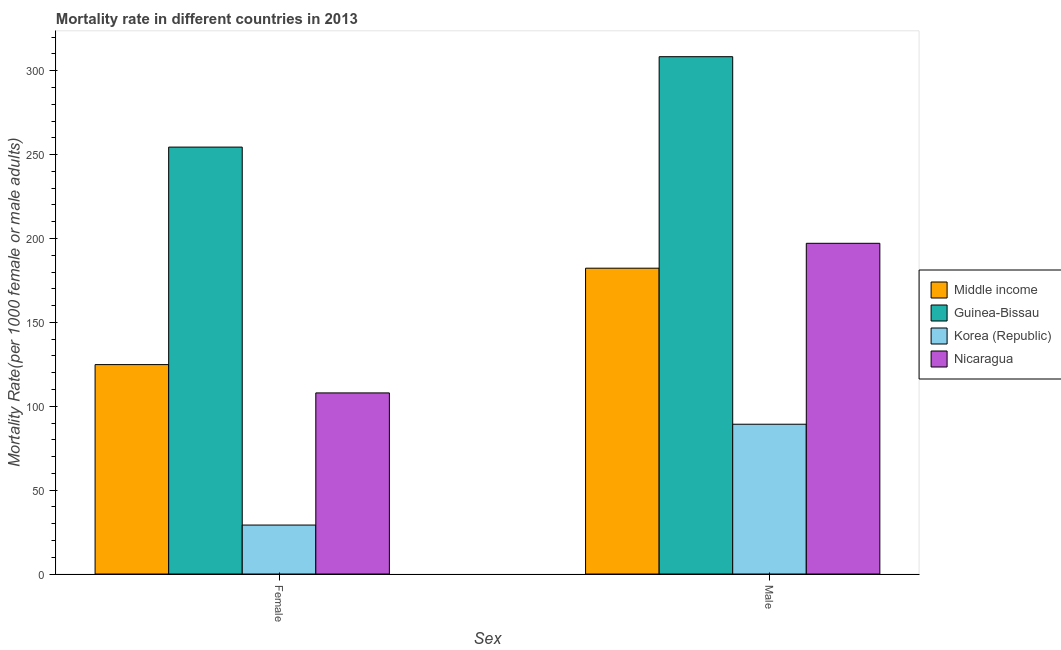How many different coloured bars are there?
Keep it short and to the point. 4. How many groups of bars are there?
Your response must be concise. 2. Are the number of bars per tick equal to the number of legend labels?
Keep it short and to the point. Yes. How many bars are there on the 1st tick from the right?
Offer a terse response. 4. What is the label of the 2nd group of bars from the left?
Provide a succinct answer. Male. What is the female mortality rate in Nicaragua?
Give a very brief answer. 107.94. Across all countries, what is the maximum female mortality rate?
Provide a short and direct response. 254.45. Across all countries, what is the minimum male mortality rate?
Your answer should be very brief. 89.27. In which country was the male mortality rate maximum?
Keep it short and to the point. Guinea-Bissau. In which country was the female mortality rate minimum?
Give a very brief answer. Korea (Republic). What is the total female mortality rate in the graph?
Keep it short and to the point. 516.38. What is the difference between the male mortality rate in Guinea-Bissau and that in Korea (Republic)?
Make the answer very short. 219.07. What is the difference between the female mortality rate in Korea (Republic) and the male mortality rate in Middle income?
Offer a very short reply. -153.11. What is the average female mortality rate per country?
Offer a terse response. 129.09. What is the difference between the female mortality rate and male mortality rate in Korea (Republic)?
Your answer should be compact. -60.1. In how many countries, is the female mortality rate greater than 120 ?
Your response must be concise. 2. What is the ratio of the male mortality rate in Korea (Republic) to that in Nicaragua?
Provide a short and direct response. 0.45. Is the male mortality rate in Middle income less than that in Guinea-Bissau?
Make the answer very short. Yes. In how many countries, is the male mortality rate greater than the average male mortality rate taken over all countries?
Offer a very short reply. 2. What does the 4th bar from the left in Male represents?
Make the answer very short. Nicaragua. How many bars are there?
Offer a terse response. 8. Are all the bars in the graph horizontal?
Provide a succinct answer. No. What is the difference between two consecutive major ticks on the Y-axis?
Provide a short and direct response. 50. Does the graph contain grids?
Your answer should be very brief. No. How many legend labels are there?
Offer a very short reply. 4. How are the legend labels stacked?
Make the answer very short. Vertical. What is the title of the graph?
Your answer should be very brief. Mortality rate in different countries in 2013. Does "Switzerland" appear as one of the legend labels in the graph?
Keep it short and to the point. No. What is the label or title of the X-axis?
Provide a succinct answer. Sex. What is the label or title of the Y-axis?
Provide a succinct answer. Mortality Rate(per 1000 female or male adults). What is the Mortality Rate(per 1000 female or male adults) in Middle income in Female?
Make the answer very short. 124.82. What is the Mortality Rate(per 1000 female or male adults) of Guinea-Bissau in Female?
Your answer should be very brief. 254.45. What is the Mortality Rate(per 1000 female or male adults) in Korea (Republic) in Female?
Give a very brief answer. 29.17. What is the Mortality Rate(per 1000 female or male adults) in Nicaragua in Female?
Ensure brevity in your answer.  107.94. What is the Mortality Rate(per 1000 female or male adults) in Middle income in Male?
Keep it short and to the point. 182.28. What is the Mortality Rate(per 1000 female or male adults) of Guinea-Bissau in Male?
Your answer should be very brief. 308.34. What is the Mortality Rate(per 1000 female or male adults) in Korea (Republic) in Male?
Your response must be concise. 89.27. What is the Mortality Rate(per 1000 female or male adults) of Nicaragua in Male?
Provide a short and direct response. 197.12. Across all Sex, what is the maximum Mortality Rate(per 1000 female or male adults) of Middle income?
Your response must be concise. 182.28. Across all Sex, what is the maximum Mortality Rate(per 1000 female or male adults) of Guinea-Bissau?
Your answer should be very brief. 308.34. Across all Sex, what is the maximum Mortality Rate(per 1000 female or male adults) in Korea (Republic)?
Give a very brief answer. 89.27. Across all Sex, what is the maximum Mortality Rate(per 1000 female or male adults) in Nicaragua?
Keep it short and to the point. 197.12. Across all Sex, what is the minimum Mortality Rate(per 1000 female or male adults) of Middle income?
Offer a very short reply. 124.82. Across all Sex, what is the minimum Mortality Rate(per 1000 female or male adults) of Guinea-Bissau?
Make the answer very short. 254.45. Across all Sex, what is the minimum Mortality Rate(per 1000 female or male adults) in Korea (Republic)?
Ensure brevity in your answer.  29.17. Across all Sex, what is the minimum Mortality Rate(per 1000 female or male adults) of Nicaragua?
Make the answer very short. 107.94. What is the total Mortality Rate(per 1000 female or male adults) of Middle income in the graph?
Offer a terse response. 307.09. What is the total Mortality Rate(per 1000 female or male adults) in Guinea-Bissau in the graph?
Ensure brevity in your answer.  562.79. What is the total Mortality Rate(per 1000 female or male adults) of Korea (Republic) in the graph?
Make the answer very short. 118.44. What is the total Mortality Rate(per 1000 female or male adults) in Nicaragua in the graph?
Ensure brevity in your answer.  305.06. What is the difference between the Mortality Rate(per 1000 female or male adults) of Middle income in Female and that in Male?
Ensure brevity in your answer.  -57.46. What is the difference between the Mortality Rate(per 1000 female or male adults) in Guinea-Bissau in Female and that in Male?
Offer a very short reply. -53.89. What is the difference between the Mortality Rate(per 1000 female or male adults) in Korea (Republic) in Female and that in Male?
Give a very brief answer. -60.1. What is the difference between the Mortality Rate(per 1000 female or male adults) in Nicaragua in Female and that in Male?
Give a very brief answer. -89.17. What is the difference between the Mortality Rate(per 1000 female or male adults) of Middle income in Female and the Mortality Rate(per 1000 female or male adults) of Guinea-Bissau in Male?
Provide a succinct answer. -183.53. What is the difference between the Mortality Rate(per 1000 female or male adults) of Middle income in Female and the Mortality Rate(per 1000 female or male adults) of Korea (Republic) in Male?
Provide a short and direct response. 35.54. What is the difference between the Mortality Rate(per 1000 female or male adults) of Middle income in Female and the Mortality Rate(per 1000 female or male adults) of Nicaragua in Male?
Your answer should be compact. -72.3. What is the difference between the Mortality Rate(per 1000 female or male adults) of Guinea-Bissau in Female and the Mortality Rate(per 1000 female or male adults) of Korea (Republic) in Male?
Your answer should be compact. 165.18. What is the difference between the Mortality Rate(per 1000 female or male adults) of Guinea-Bissau in Female and the Mortality Rate(per 1000 female or male adults) of Nicaragua in Male?
Give a very brief answer. 57.34. What is the difference between the Mortality Rate(per 1000 female or male adults) of Korea (Republic) in Female and the Mortality Rate(per 1000 female or male adults) of Nicaragua in Male?
Offer a terse response. -167.94. What is the average Mortality Rate(per 1000 female or male adults) of Middle income per Sex?
Your response must be concise. 153.55. What is the average Mortality Rate(per 1000 female or male adults) of Guinea-Bissau per Sex?
Offer a terse response. 281.4. What is the average Mortality Rate(per 1000 female or male adults) in Korea (Republic) per Sex?
Provide a succinct answer. 59.22. What is the average Mortality Rate(per 1000 female or male adults) of Nicaragua per Sex?
Offer a very short reply. 152.53. What is the difference between the Mortality Rate(per 1000 female or male adults) of Middle income and Mortality Rate(per 1000 female or male adults) of Guinea-Bissau in Female?
Keep it short and to the point. -129.64. What is the difference between the Mortality Rate(per 1000 female or male adults) in Middle income and Mortality Rate(per 1000 female or male adults) in Korea (Republic) in Female?
Offer a very short reply. 95.64. What is the difference between the Mortality Rate(per 1000 female or male adults) in Middle income and Mortality Rate(per 1000 female or male adults) in Nicaragua in Female?
Your response must be concise. 16.88. What is the difference between the Mortality Rate(per 1000 female or male adults) of Guinea-Bissau and Mortality Rate(per 1000 female or male adults) of Korea (Republic) in Female?
Offer a terse response. 225.28. What is the difference between the Mortality Rate(per 1000 female or male adults) in Guinea-Bissau and Mortality Rate(per 1000 female or male adults) in Nicaragua in Female?
Your answer should be compact. 146.51. What is the difference between the Mortality Rate(per 1000 female or male adults) of Korea (Republic) and Mortality Rate(per 1000 female or male adults) of Nicaragua in Female?
Keep it short and to the point. -78.77. What is the difference between the Mortality Rate(per 1000 female or male adults) in Middle income and Mortality Rate(per 1000 female or male adults) in Guinea-Bissau in Male?
Keep it short and to the point. -126.06. What is the difference between the Mortality Rate(per 1000 female or male adults) in Middle income and Mortality Rate(per 1000 female or male adults) in Korea (Republic) in Male?
Your answer should be very brief. 93.01. What is the difference between the Mortality Rate(per 1000 female or male adults) in Middle income and Mortality Rate(per 1000 female or male adults) in Nicaragua in Male?
Keep it short and to the point. -14.84. What is the difference between the Mortality Rate(per 1000 female or male adults) in Guinea-Bissau and Mortality Rate(per 1000 female or male adults) in Korea (Republic) in Male?
Provide a succinct answer. 219.07. What is the difference between the Mortality Rate(per 1000 female or male adults) of Guinea-Bissau and Mortality Rate(per 1000 female or male adults) of Nicaragua in Male?
Your response must be concise. 111.23. What is the difference between the Mortality Rate(per 1000 female or male adults) in Korea (Republic) and Mortality Rate(per 1000 female or male adults) in Nicaragua in Male?
Your answer should be compact. -107.84. What is the ratio of the Mortality Rate(per 1000 female or male adults) in Middle income in Female to that in Male?
Ensure brevity in your answer.  0.68. What is the ratio of the Mortality Rate(per 1000 female or male adults) in Guinea-Bissau in Female to that in Male?
Ensure brevity in your answer.  0.83. What is the ratio of the Mortality Rate(per 1000 female or male adults) of Korea (Republic) in Female to that in Male?
Make the answer very short. 0.33. What is the ratio of the Mortality Rate(per 1000 female or male adults) of Nicaragua in Female to that in Male?
Offer a very short reply. 0.55. What is the difference between the highest and the second highest Mortality Rate(per 1000 female or male adults) in Middle income?
Provide a short and direct response. 57.46. What is the difference between the highest and the second highest Mortality Rate(per 1000 female or male adults) in Guinea-Bissau?
Make the answer very short. 53.89. What is the difference between the highest and the second highest Mortality Rate(per 1000 female or male adults) of Korea (Republic)?
Make the answer very short. 60.1. What is the difference between the highest and the second highest Mortality Rate(per 1000 female or male adults) in Nicaragua?
Ensure brevity in your answer.  89.17. What is the difference between the highest and the lowest Mortality Rate(per 1000 female or male adults) of Middle income?
Provide a short and direct response. 57.46. What is the difference between the highest and the lowest Mortality Rate(per 1000 female or male adults) of Guinea-Bissau?
Ensure brevity in your answer.  53.89. What is the difference between the highest and the lowest Mortality Rate(per 1000 female or male adults) in Korea (Republic)?
Give a very brief answer. 60.1. What is the difference between the highest and the lowest Mortality Rate(per 1000 female or male adults) of Nicaragua?
Keep it short and to the point. 89.17. 